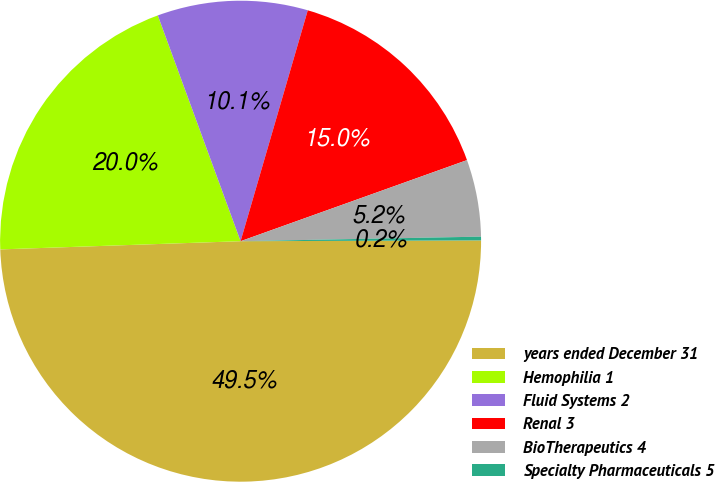Convert chart to OTSL. <chart><loc_0><loc_0><loc_500><loc_500><pie_chart><fcel>years ended December 31<fcel>Hemophilia 1<fcel>Fluid Systems 2<fcel>Renal 3<fcel>BioTherapeutics 4<fcel>Specialty Pharmaceuticals 5<nl><fcel>49.51%<fcel>19.95%<fcel>10.1%<fcel>15.02%<fcel>5.17%<fcel>0.25%<nl></chart> 